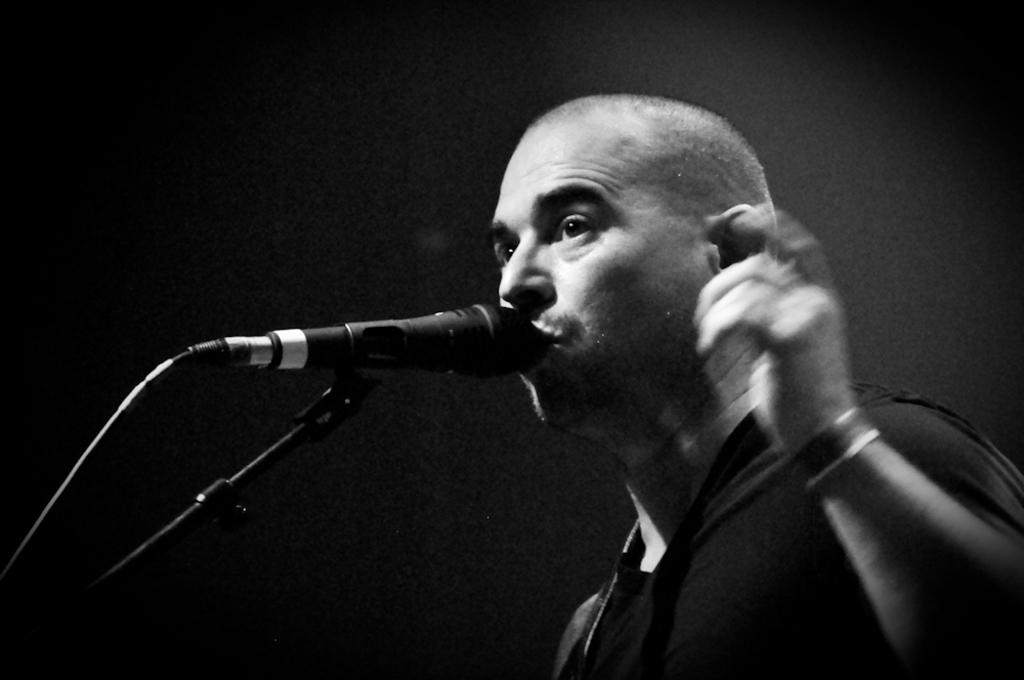What is the color scheme of the image? The image is black and white. Who is in the image? There is a man in the image. What object is in front of the man? A microphone is present in front of the man. What type of tooth is visible in the image? There is no tooth visible in the image. What activity is the man participating in with the microphone? The image does not provide enough information to determine the activity the man is participating in with the microphone. 